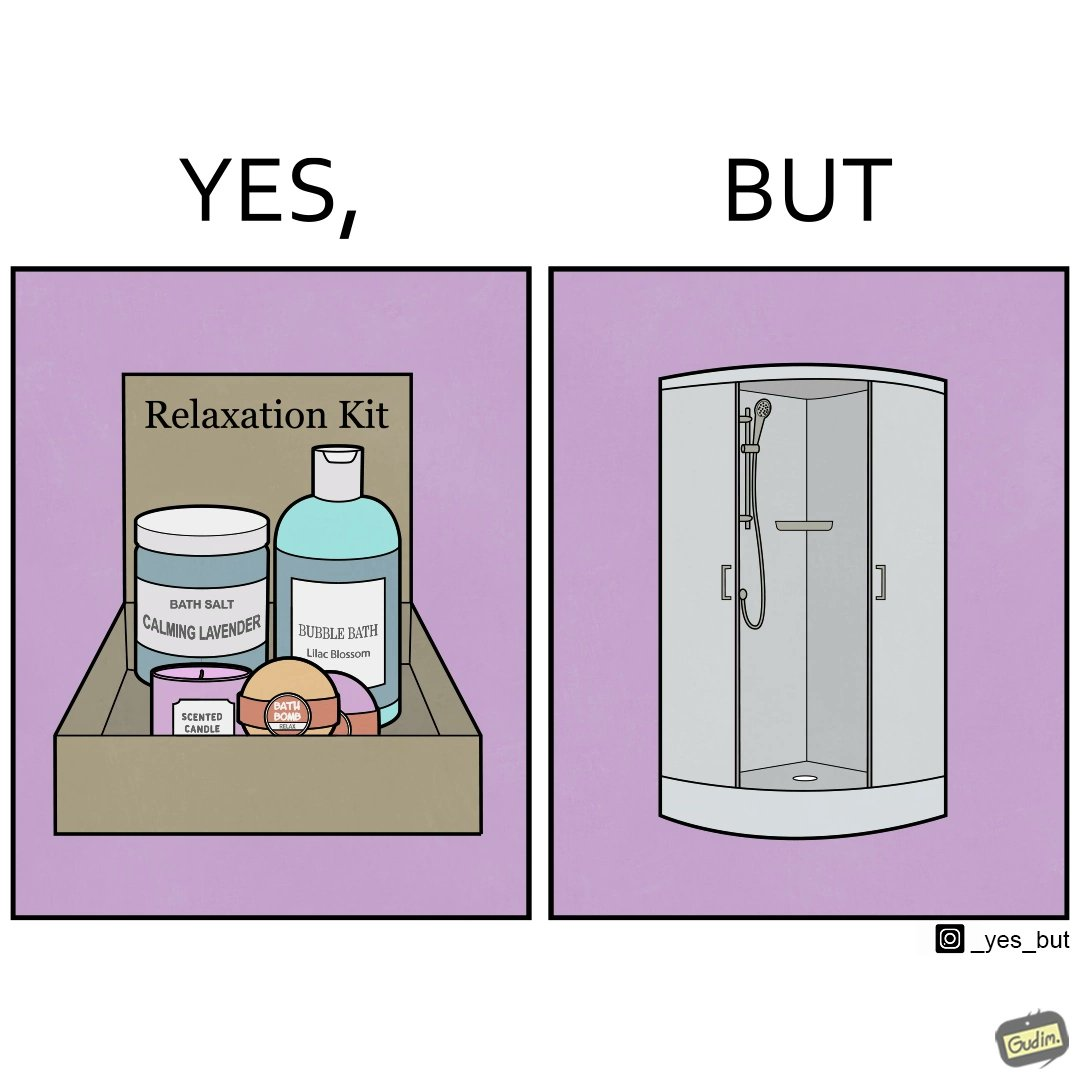Describe the content of this image. The image is ironical, as the relaxation kit is meant to relax and calm down the person using it during a bath, but the showering area is an enclosed space, which might instead tense up someone, especially if the person is claustrophobic. 